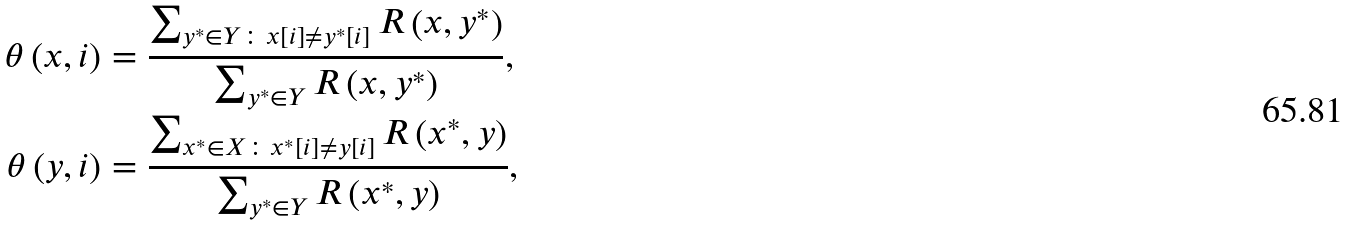Convert formula to latex. <formula><loc_0><loc_0><loc_500><loc_500>\theta \left ( x , i \right ) & = \frac { \sum _ { y ^ { \ast } \in Y \colon x \left [ i \right ] \neq y ^ { \ast } \left [ i \right ] } R \left ( x , y ^ { \ast } \right ) } { \sum _ { y ^ { \ast } \in Y } R \left ( x , y ^ { \ast } \right ) } , \\ \theta \left ( y , i \right ) & = \frac { \sum _ { x ^ { \ast } \in X \colon x ^ { \ast } \left [ i \right ] \neq y \left [ i \right ] } R \left ( x ^ { \ast } , y \right ) } { \sum _ { y ^ { \ast } \in Y } R \left ( x ^ { \ast } , y \right ) } ,</formula> 